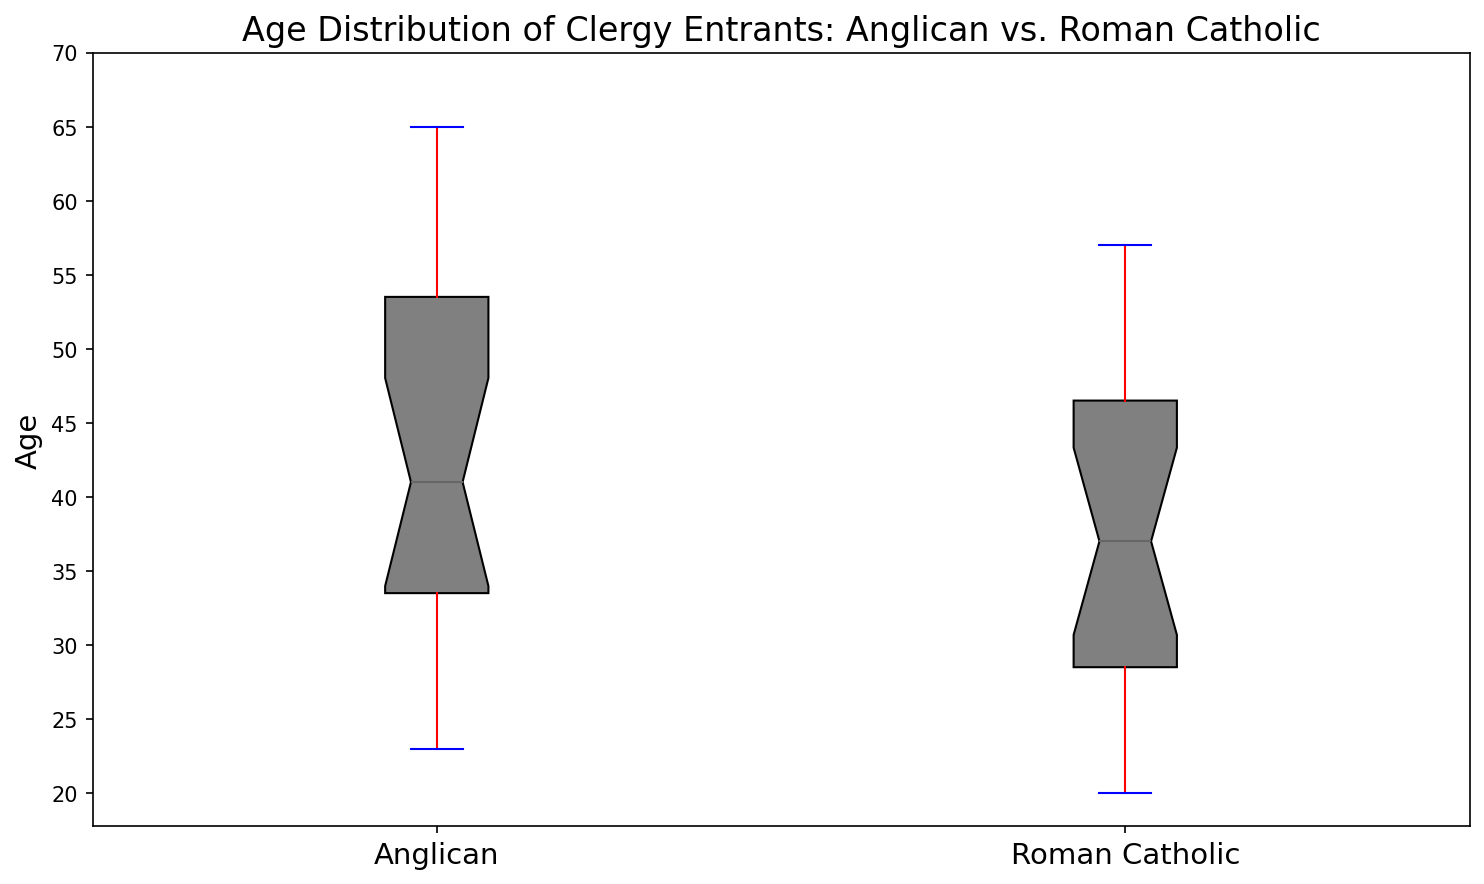Which denomination has the greater median age of entrants? The figure's box plots show the median as the central line inside the box. By observation, the central line in the Anglican box is higher than that in the Roman Catholic box, indicating that the median age of Anglican entrants is greater.
Answer: Anglican What is the difference between the median ages of the two denominations? The median age is the central line of the box. For Anglicans, it appears around 42 years, and for Roman Catholics, it appears around 36 years. The difference is 42 - 36.
Answer: 6 years Which denomination has a greater spread in the age distribution of entrants? The spread of the age distribution is shown by the length of the box combined with the whiskers. The Anglican box plot extends from about 20 to 65, whereas the Roman Catholic extends from about 20 to 57. The Anglican denomination has a greater spread.
Answer: Anglican Are there any outliers in the age data of either denomination? Outliers would be represented by individual points outside the whiskers. In the figure, there are no such individual points visible, so there are no outliers for either denomination.
Answer: No Which denomination has the earlier entry age of entrants, considering the lower whisker? The lower whisker indicates the minimum non-outlier age. For both Anglicans and Roman Catholics, the lower whisker is at the same position, which is around 20 years.
Answer: Both are equally early What is the interquartile range (IQR) for the age distribution of Anglican entrants? The IQR is the range from the lower quartile to the upper quartile (bottom and top edges of the box). Observing the plot, these edges are at about 28 and 55 years respectively. The IQR is 55 - 28.
Answer: 27 years What's the difference between the upper whisker values of Anglican and Roman Catholic age distributions? The upper whisker shows the maximum age before outliers. The Anglican upper whisker is at around 65 years, while the Roman Catholic upper whisker is around 57 years. The difference is 65 - 57.
Answer: 8 years Between the two denominations, which has a more consistent age distribution of entrants? A more consistent (less variable) age distribution has a smaller IQR. The Roman Catholic denomination has a smaller box (IQR) compared to the Anglican denomination, indicating a more consistent age distribution.
Answer: Roman Catholic Where does the third quartile (75th percentile) fall for Roman Catholic entrants? The third quartile is the top edge of the box plot. For Roman Catholic, this edge appears around 48 years on the plot.
Answer: 48 years 